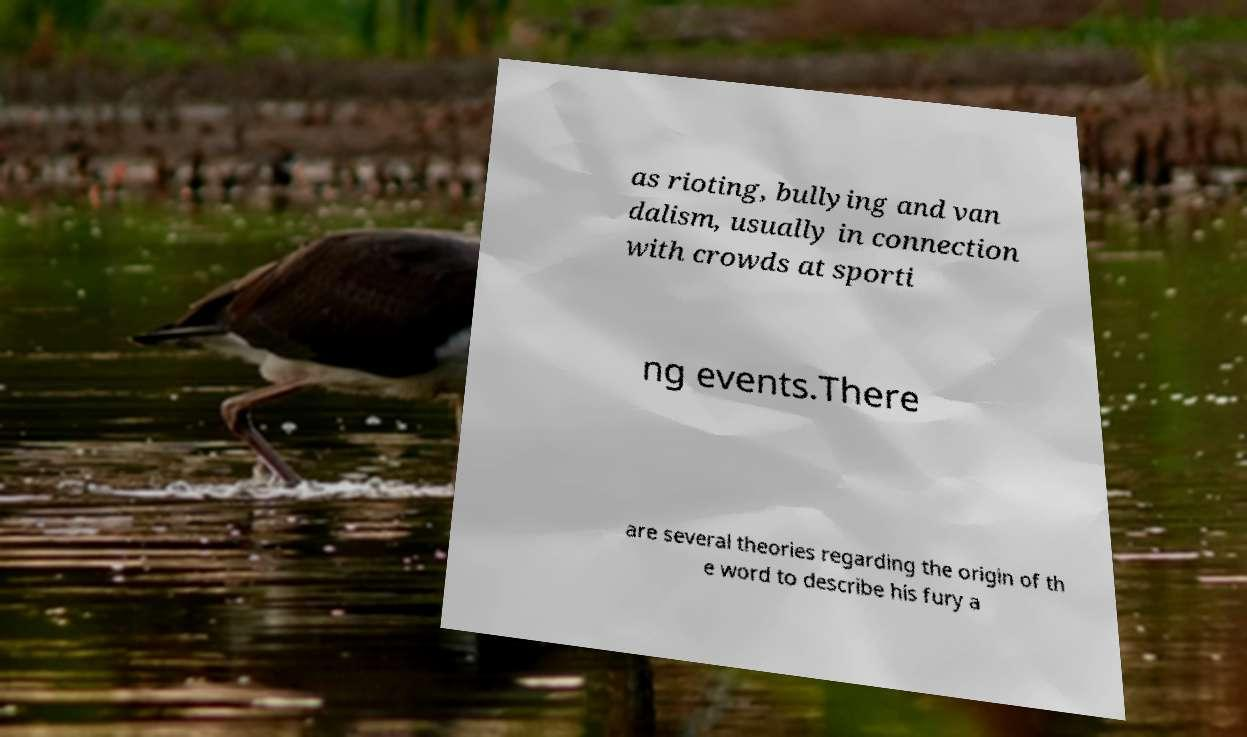I need the written content from this picture converted into text. Can you do that? as rioting, bullying and van dalism, usually in connection with crowds at sporti ng events.There are several theories regarding the origin of th e word to describe his fury a 